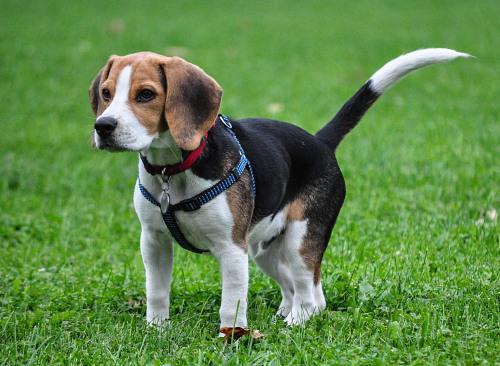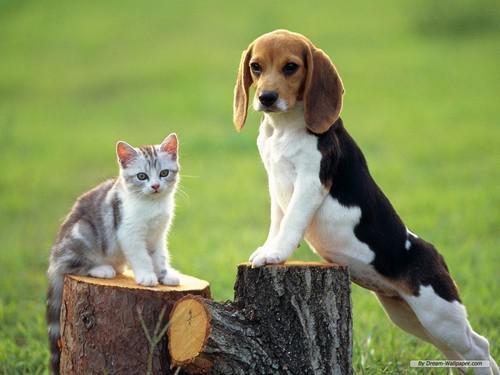The first image is the image on the left, the second image is the image on the right. Assess this claim about the two images: "An image contains an animal that is not a floppy-eared beagle.". Correct or not? Answer yes or no. Yes. The first image is the image on the left, the second image is the image on the right. Evaluate the accuracy of this statement regarding the images: "The puppy in the right image is bounding across the grass.". Is it true? Answer yes or no. No. 